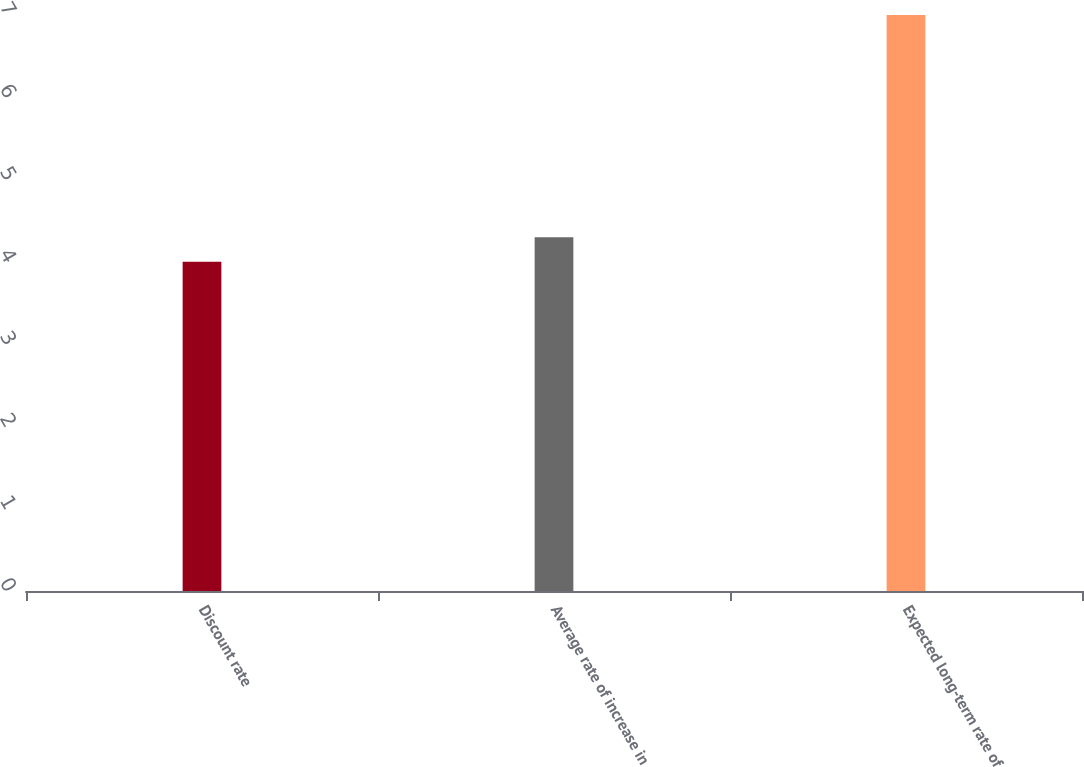Convert chart to OTSL. <chart><loc_0><loc_0><loc_500><loc_500><bar_chart><fcel>Discount rate<fcel>Average rate of increase in<fcel>Expected long-term rate of<nl><fcel>4<fcel>4.3<fcel>7<nl></chart> 